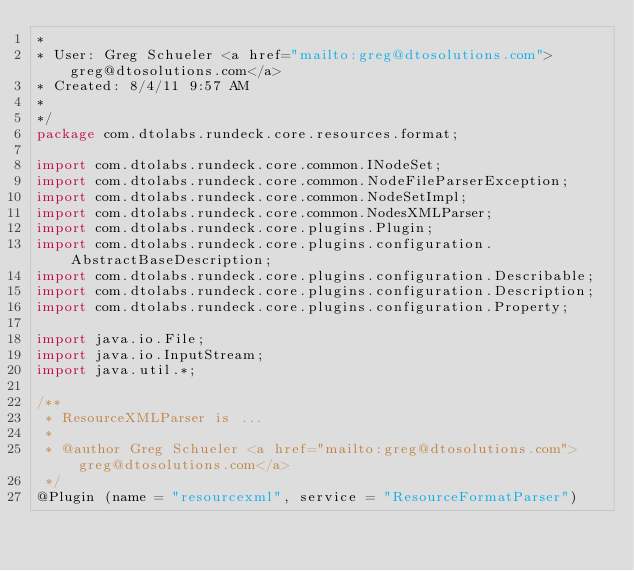<code> <loc_0><loc_0><loc_500><loc_500><_Java_>* 
* User: Greg Schueler <a href="mailto:greg@dtosolutions.com">greg@dtosolutions.com</a>
* Created: 8/4/11 9:57 AM
* 
*/
package com.dtolabs.rundeck.core.resources.format;

import com.dtolabs.rundeck.core.common.INodeSet;
import com.dtolabs.rundeck.core.common.NodeFileParserException;
import com.dtolabs.rundeck.core.common.NodeSetImpl;
import com.dtolabs.rundeck.core.common.NodesXMLParser;
import com.dtolabs.rundeck.core.plugins.Plugin;
import com.dtolabs.rundeck.core.plugins.configuration.AbstractBaseDescription;
import com.dtolabs.rundeck.core.plugins.configuration.Describable;
import com.dtolabs.rundeck.core.plugins.configuration.Description;
import com.dtolabs.rundeck.core.plugins.configuration.Property;

import java.io.File;
import java.io.InputStream;
import java.util.*;

/**
 * ResourceXMLParser is ...
 *
 * @author Greg Schueler <a href="mailto:greg@dtosolutions.com">greg@dtosolutions.com</a>
 */
@Plugin (name = "resourcexml", service = "ResourceFormatParser")</code> 